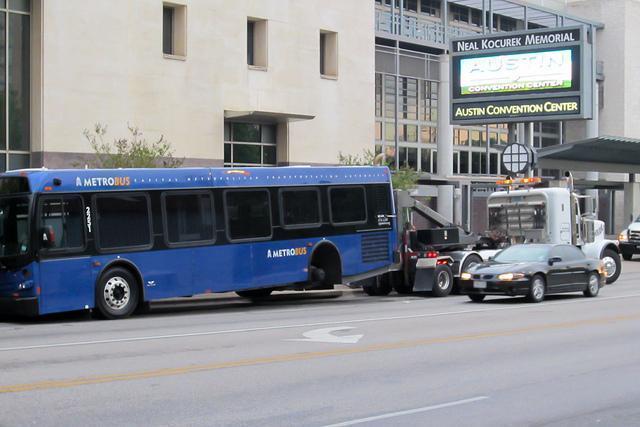In which state is this bus being towed?
Select the accurate answer and provide explanation: 'Answer: answer
Rationale: rationale.'
Options: Texas, new mexico, kansas, mass. Answer: texas.
Rationale: In the background of the image there is a sign for the austin convention center. austin is a city in texas. 